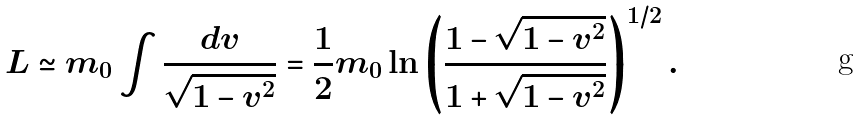Convert formula to latex. <formula><loc_0><loc_0><loc_500><loc_500>L \simeq m _ { 0 } \int \frac { d v } { \sqrt { 1 - v ^ { 2 } } } = \frac { 1 } { 2 } m _ { 0 } \ln \left ( \frac { 1 - \sqrt { 1 - v ^ { 2 } } } { 1 + \sqrt { 1 - v ^ { 2 } } } \right ) ^ { 1 / 2 } .</formula> 